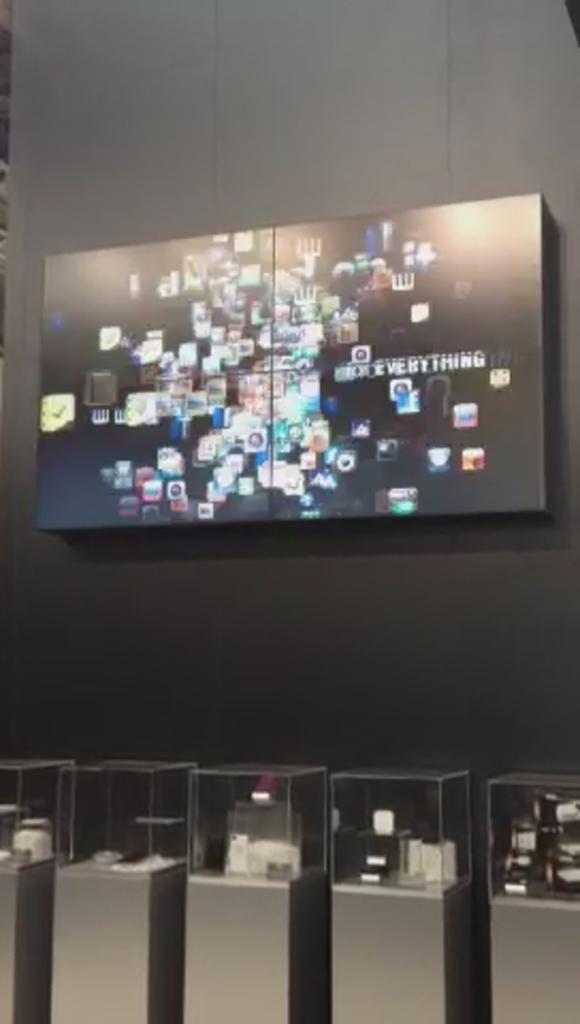What is the art piece labeled?
Provide a short and direct response. Everything. 